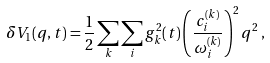<formula> <loc_0><loc_0><loc_500><loc_500>\delta V _ { 1 } ( q , t ) = \frac { 1 } { 2 } \sum _ { k } \sum _ { i } g _ { k } ^ { 2 } ( t ) \left ( \frac { c ^ { ( k ) } _ { i } } { \omega _ { i } ^ { ( k ) } } \right ) ^ { 2 } q ^ { 2 } \, ,</formula> 